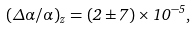Convert formula to latex. <formula><loc_0><loc_0><loc_500><loc_500>( \Delta \alpha / \alpha ) _ { z } = ( 2 \pm 7 ) \times 1 0 ^ { - 5 } ,</formula> 